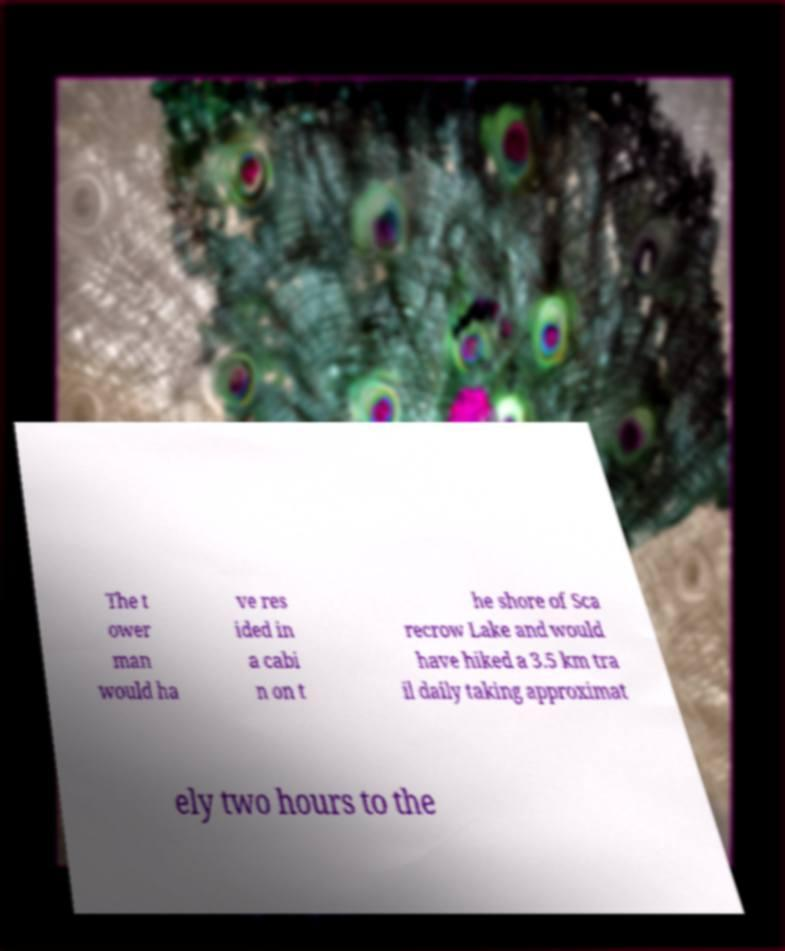What messages or text are displayed in this image? I need them in a readable, typed format. The t ower man would ha ve res ided in a cabi n on t he shore of Sca recrow Lake and would have hiked a 3.5 km tra il daily taking approximat ely two hours to the 